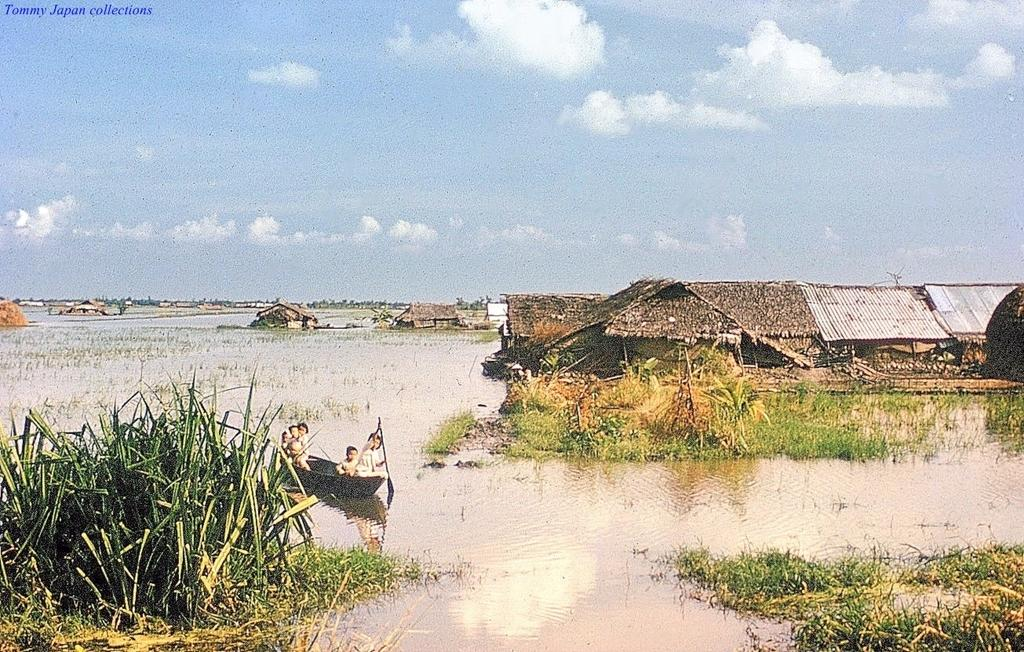What are the people in the image doing? The people in the image are sitting on a boat. Where is the boat located? The boat is on the water. What can be seen in the background of the image? There are houses, trees, and the sky visible in the background of the image. What type of dinosaurs can be seen swimming in the water near the boat? There are no dinosaurs present in the image; it features people sitting on a boat on the water. 